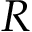Convert formula to latex. <formula><loc_0><loc_0><loc_500><loc_500>R</formula> 